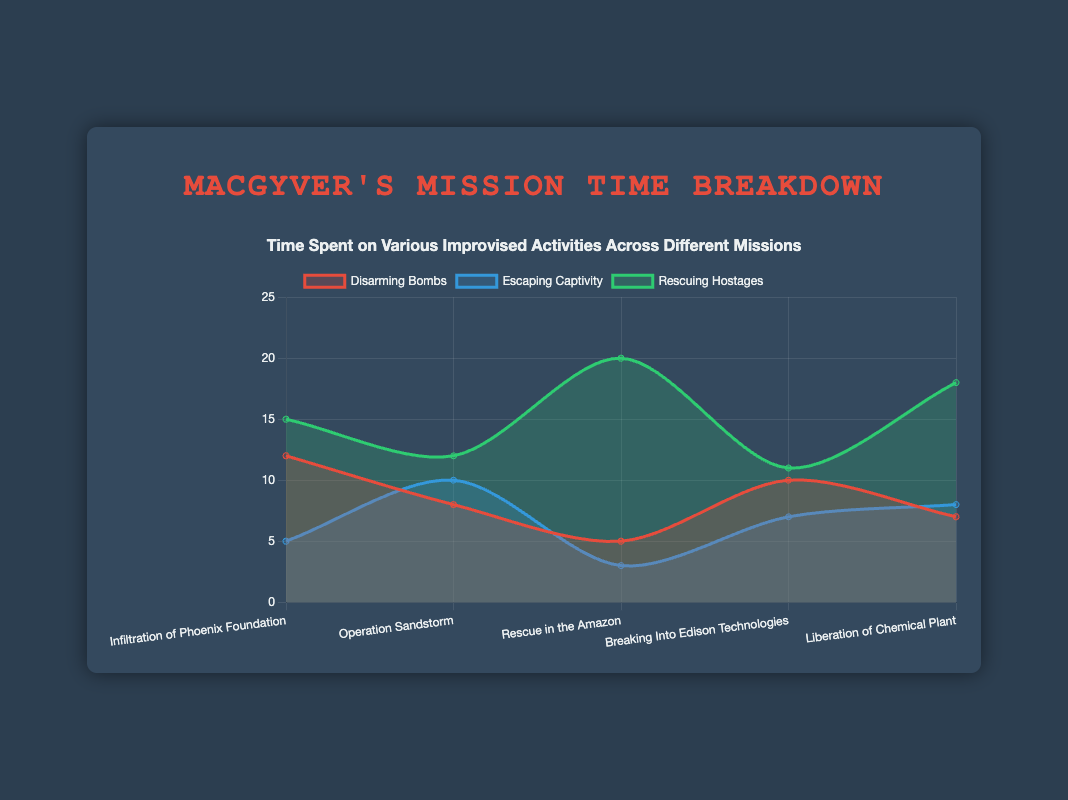What is the title of the figure? The title of the figure is displayed prominently at the top of the chart.
Answer: MacGyver's Mission Time Breakdown How many missions are displayed in the chart? Count the number of distinct mission names along the x-axis of the chart.
Answer: 5 Which activity takes the most time in the "Rescue in the Amazon" mission? Look at the data points corresponding to "Rescue in the Amazon" for the three activities: disarming bombs, escaping captivity, rescuing hostages. "Rescuing hostages" has the highest value.
Answer: Rescuing hostages How much time did MacGyver spend on "disarming bombs" across all missions combined? Add the values for "disarming bombs" across all missions: 12 + 8 + 5 + 10 + 7 = 42.
Answer: 42 Which mission has the highest total time spent on all activities combined? Sum the time spent on all activities for each mission and identify the mission with the highest total: Infiltration of Phoenix Foundation (32), Operation Sandstorm (30), Rescue in the Amazon (28), Breaking Into Edison Technologies (28), Liberation of Chemical Plant (33). "Liberation of Chemical Plant" has the highest total.
Answer: Liberation of Chemical Plant Did MacGyver spend more time escaping captivity in "Operation Sandstorm" or "Liberation of Chemical Plant"? Compare the values: "Operation Sandstorm" (10) vs. "Liberation of Chemical Plant" (8). He spent more time in "Operation Sandstorm".
Answer: Operation Sandstorm What is the average time spent on rescuing hostages across all missions? Add the time spent on rescuing hostages across all missions and divide by the number of missions: (15 + 12 + 20 + 11 + 18) / 5 = 76 / 5 = 15.2.
Answer: 15.2 Which mission shows the least time spent on escaping captivity? Identify the smallest value for escaping captivity across all missions: "Rescue in the Amazon" with 3.
Answer: Rescue in the Amazon How does the time spent on disarming bombs in "Infiltration of Phoenix Foundation" compare to "Breaking Into Edison Technologies"? Compare the values: "Infiltration of Phoenix Foundation" (12) vs. "Breaking Into Edison Technologies" (10). "Infiltration of Phoenix Foundation" is higher.
Answer: Infiltration of Phoenix Foundation If you add the time spent on disarming bombs and escaping captivity in "Operation Sandstorm", what is the sum? Add the values for disarming bombs and escaping captivity in "Operation Sandstorm": 8 + 10 = 18.
Answer: 18 